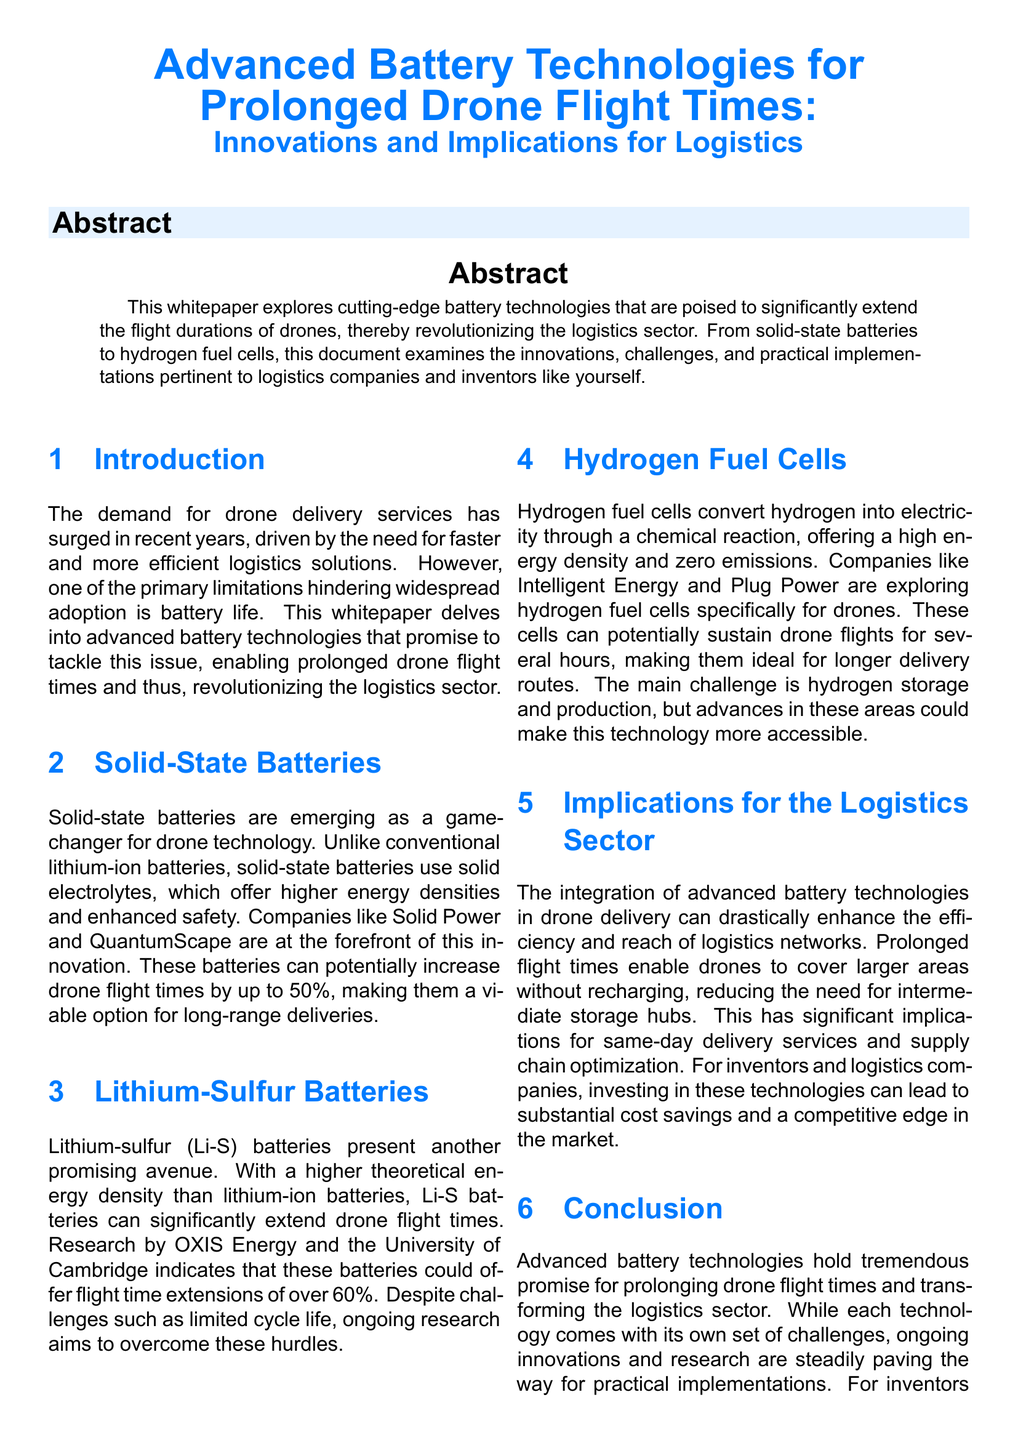What is the primary limitation hindering widespread adoption of drone delivery? The primary limitation discussed in the document is battery life.
Answer: battery life What percentage increase in flight times do solid-state batteries potentially offer? The document states that solid-state batteries can potentially increase drone flight times by up to 50%.
Answer: 50% Which company is exploring lithium-sulfur batteries? OXIS Energy is mentioned as a company researching lithium-sulfur batteries.
Answer: OXIS Energy What is a significant challenge for hydrogen fuel cells in drones? The main challenge identified for hydrogen fuel cells is hydrogen storage and production.
Answer: hydrogen storage and production What are the potential benefits of integrating advanced battery technologies in logistics? The document suggests that it can enhance the efficiency and reach of logistics networks.
Answer: efficiency and reach What type of battery uses solid electrolytes? Solid-state batteries use solid electrolytes.
Answer: Solid-state batteries Which technology could extend drone flight times by over 60%? Lithium-sulfur batteries could offer flight time extensions of over 60%.
Answer: Lithium-sulfur batteries Who are the companies mentioned that are exploring hydrogen fuel cells? Intelligent Energy and Plug Power are mentioned as companies exploring hydrogen fuel cells.
Answer: Intelligent Energy and Plug Power In which section is the implication of battery technologies on logistics discussed? The implications for the logistics sector are discussed in the corresponding section labeled "Implications for the Logistics Sector."
Answer: Implications for the Logistics Sector 